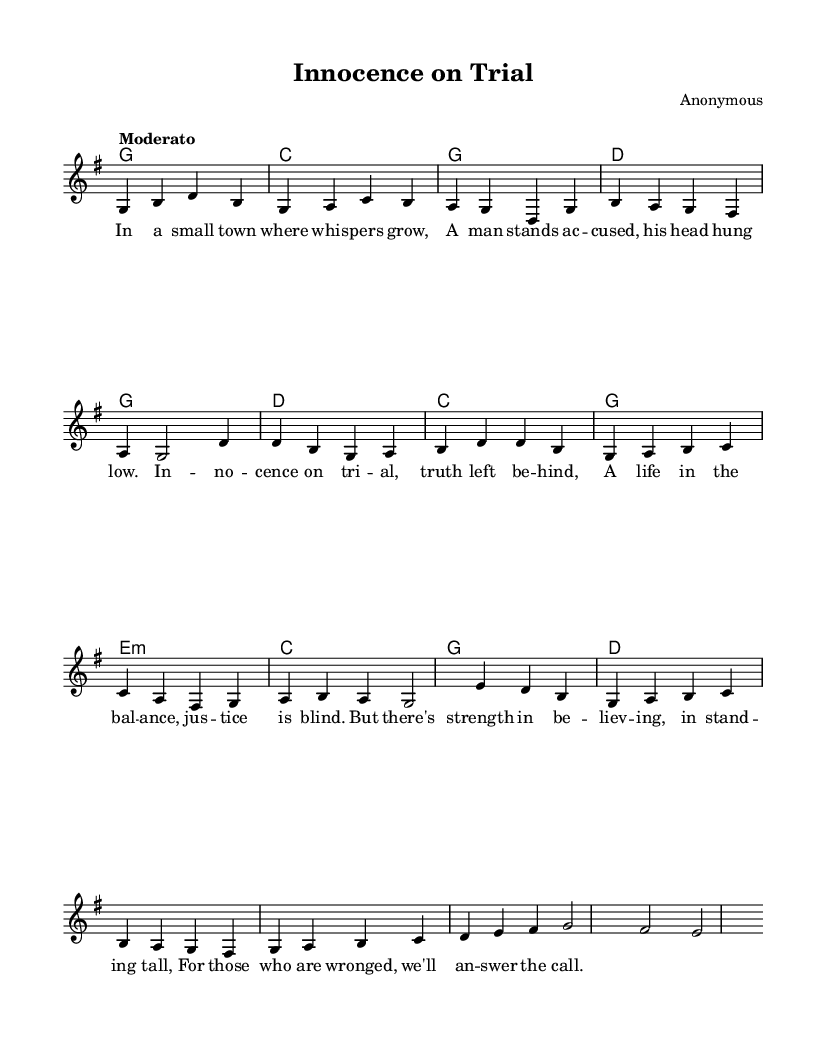What is the key signature of this music? The key signature is G major, which has one sharp (F#). This is indicated at the start of the sheet music.
Answer: G major What is the time signature of this music? The time signature is 4/4, indicated at the beginning of the score. This means there are four beats in each measure.
Answer: 4/4 What is the tempo marking of this piece? The tempo marking is "Moderato," indicating a moderate pace. It can be found after the time signature in the global section.
Answer: Moderato How many measures are in the verse section? The verse section consists of four measures, as counted in the melody notation where each grouping with a vertical line represents one measure.
Answer: 4 Identify the starting note of the chorus. The starting note of the chorus is D, which is the first note of the chorus melody indicated in the sheet music.
Answer: D Which chord is played during the first measure of the verse? The first measure of the verse has a G chord, which is evident in the harmonies section where the corresponding chord symbol is shown.
Answer: G What theme does the song reflect? The song reflects the theme of innocence and the wrongly accused, as suggested by the lyrics provided in the verse section.
Answer: Innocence 